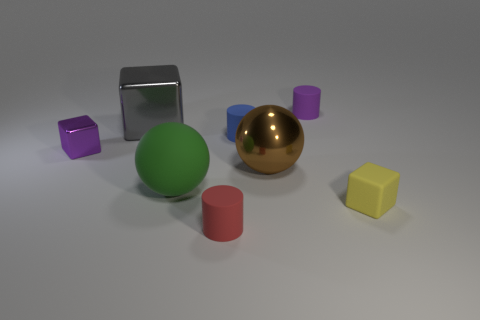Subtract all green cubes. Subtract all yellow spheres. How many cubes are left? 3 Add 1 brown metal balls. How many objects exist? 9 Subtract all cubes. How many objects are left? 5 Add 8 big gray things. How many big gray things exist? 9 Subtract 1 yellow cubes. How many objects are left? 7 Subtract all blue cylinders. Subtract all tiny blocks. How many objects are left? 5 Add 7 large metallic spheres. How many large metallic spheres are left? 8 